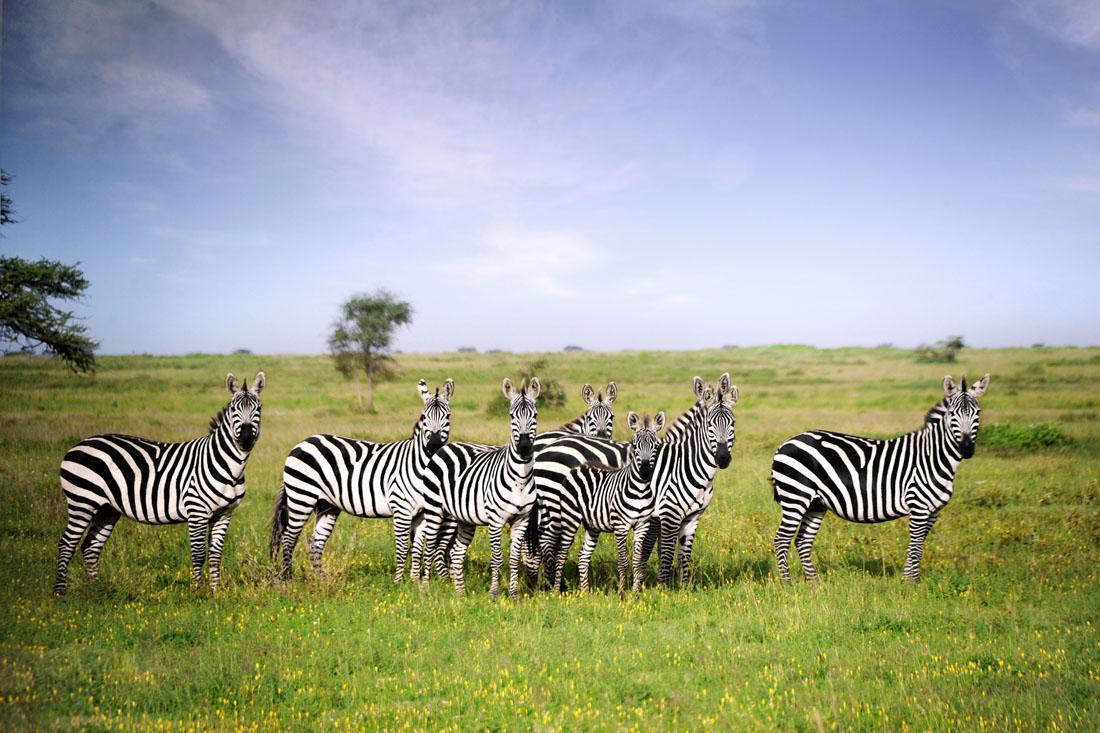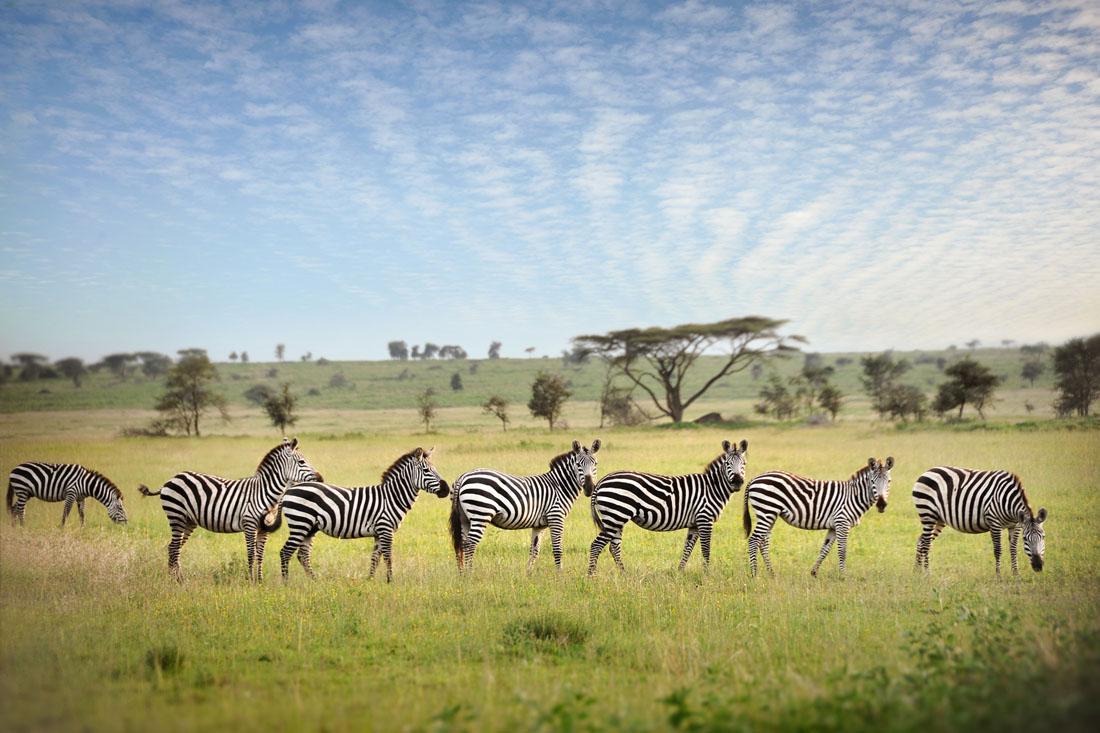The first image is the image on the left, the second image is the image on the right. Analyze the images presented: Is the assertion "At least one image shows a row of zebras in similar poses in terms of the way their bodies are turned and their eyes are gazing." valid? Answer yes or no. Yes. 